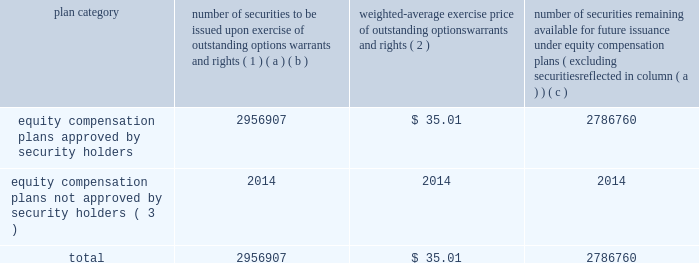Equity compensation plan information the table presents the equity securities available for issuance under our equity compensation plans as of december 31 , 2013 .
Equity compensation plan information plan category number of securities to be issued upon exercise of outstanding options , warrants and rights ( 1 ) weighted-average exercise price of outstanding options , warrants and rights ( 2 ) number of securities remaining available for future issuance under equity compensation plans ( excluding securities reflected in column ( a ) ) ( a ) ( b ) ( c ) equity compensation plans approved by security holders 2956907 $ 35.01 2786760 equity compensation plans not approved by security holders ( 3 ) 2014 2014 2014 .
( 1 ) includes grants made under the huntington ingalls industries , inc .
2012 long-term incentive stock plan ( the "2012 plan" ) , which was approved by our stockholders on may 2 , 2012 , and the huntington ingalls industries , inc .
2011 long-term incentive stock plan ( the "2011 plan" ) , which was approved by the sole stockholder of hii prior to its spin-off from northrop grumman corporation .
Of these shares , 818723 were subject to stock options , 1002217 were subject to outstanding restricted performance stock rights , 602400 were restricted stock rights , and 63022 were stock rights granted under the 2011 plan .
In addition , this number includes 24428 stock rights and 446117 restricted performance stock rights granted under the 2012 plan , assuming target performance achievement .
( 2 ) this is the weighted average exercise price of the 818723 outstanding stock options only .
( 3 ) there are no awards made under plans not approved by security holders .
Item 13 .
Certain relationships and related transactions , and director independence information as to certain relationships and related transactions and director independence will be incorporated herein by reference to the proxy statement for our 2014 annual meeting of stockholders to be filed within 120 days after the end of the company 2019s fiscal year .
Item 14 .
Principal accountant fees and services information as to principal accountant fees and services will be incorporated herein by reference to the proxy statement for our 2014 annual meeting of stockholders to be filed within 120 days after the end of the company 2019s fiscal year. .
What portion of the equity compensation plan approved by security holders remains available for future issuance? 
Computations: (2786760 / (2956907 + 2786760))
Answer: 0.48519. 